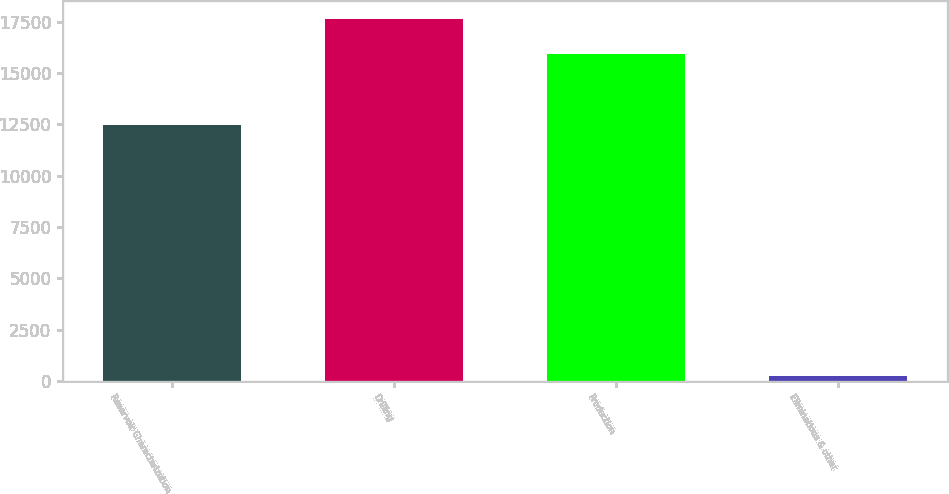<chart> <loc_0><loc_0><loc_500><loc_500><bar_chart><fcel>Reservoir Characterization<fcel>Drilling<fcel>Production<fcel>Eliminations & other<nl><fcel>12463<fcel>17614.6<fcel>15927<fcel>223<nl></chart> 